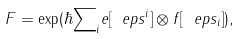Convert formula to latex. <formula><loc_0><loc_0><loc_500><loc_500>F = \exp ( \hbar { \sum } _ { i } e [ \ e p s ^ { i } ] \otimes f [ \ e p s _ { i } ] ) ,</formula> 